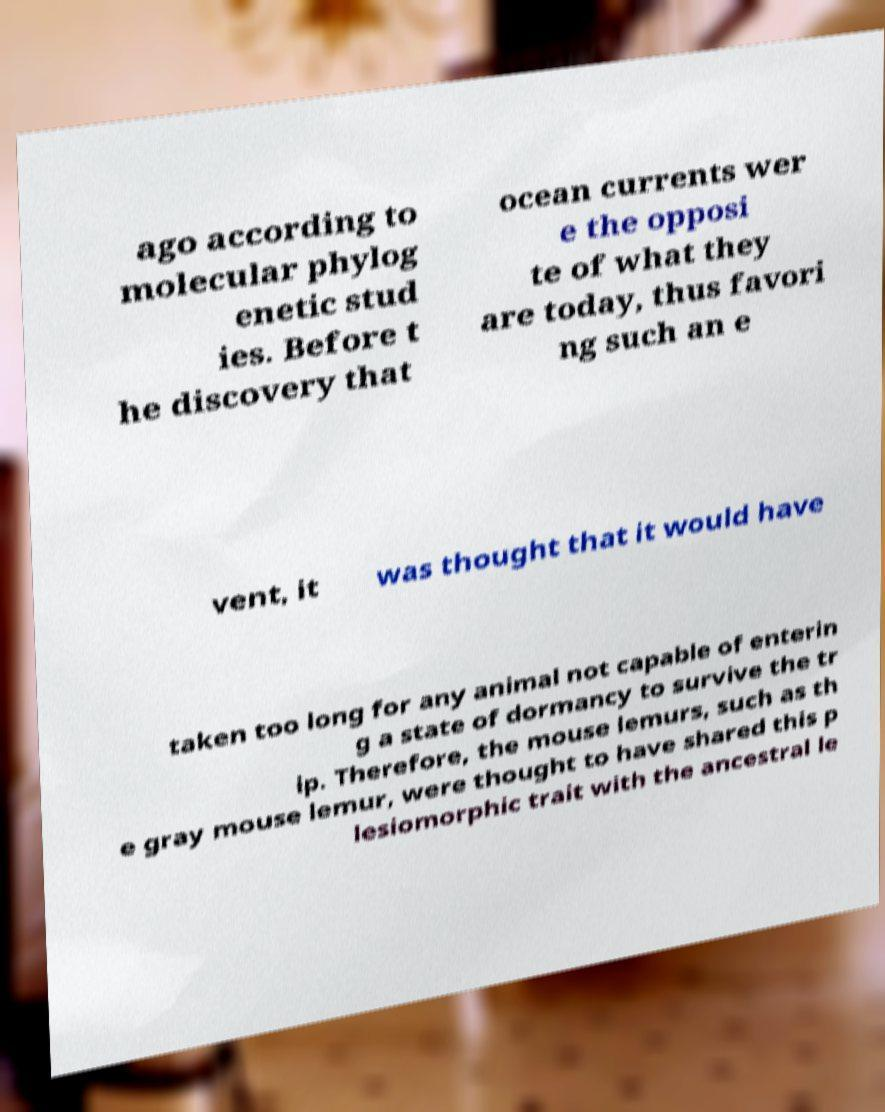What messages or text are displayed in this image? I need them in a readable, typed format. ago according to molecular phylog enetic stud ies. Before t he discovery that ocean currents wer e the opposi te of what they are today, thus favori ng such an e vent, it was thought that it would have taken too long for any animal not capable of enterin g a state of dormancy to survive the tr ip. Therefore, the mouse lemurs, such as th e gray mouse lemur, were thought to have shared this p lesiomorphic trait with the ancestral le 